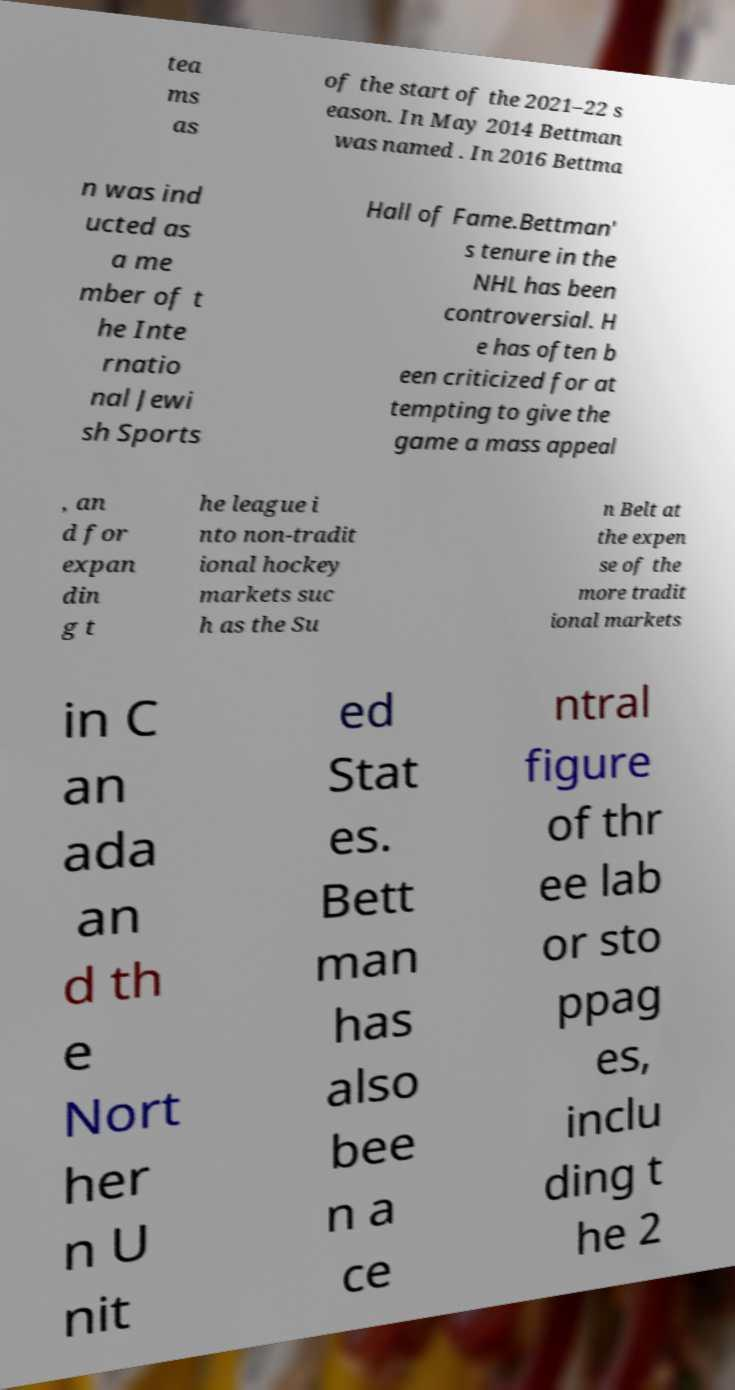Please identify and transcribe the text found in this image. tea ms as of the start of the 2021–22 s eason. In May 2014 Bettman was named . In 2016 Bettma n was ind ucted as a me mber of t he Inte rnatio nal Jewi sh Sports Hall of Fame.Bettman' s tenure in the NHL has been controversial. H e has often b een criticized for at tempting to give the game a mass appeal , an d for expan din g t he league i nto non-tradit ional hockey markets suc h as the Su n Belt at the expen se of the more tradit ional markets in C an ada an d th e Nort her n U nit ed Stat es. Bett man has also bee n a ce ntral figure of thr ee lab or sto ppag es, inclu ding t he 2 